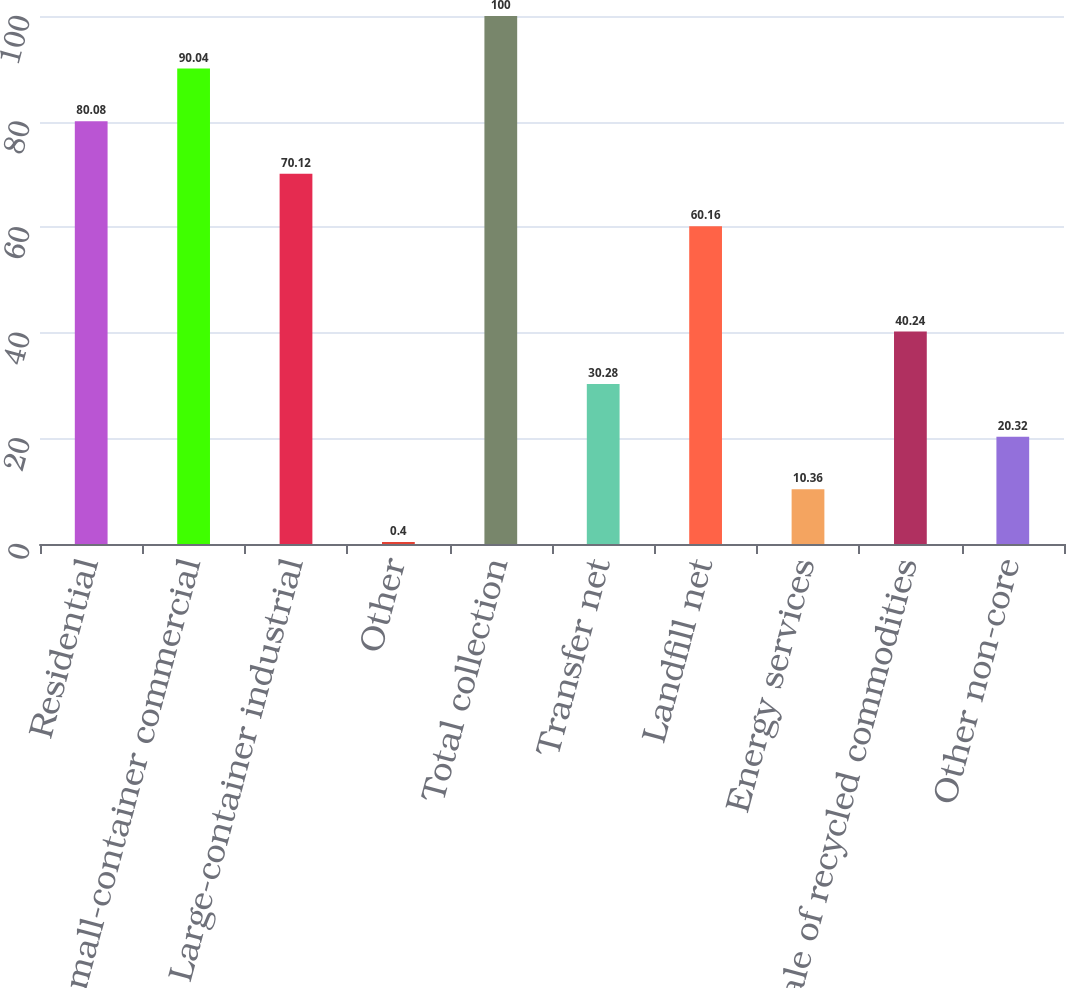<chart> <loc_0><loc_0><loc_500><loc_500><bar_chart><fcel>Residential<fcel>Small-container commercial<fcel>Large-container industrial<fcel>Other<fcel>Total collection<fcel>Transfer net<fcel>Landfill net<fcel>Energy services<fcel>Sale of recycled commodities<fcel>Other non-core<nl><fcel>80.08<fcel>90.04<fcel>70.12<fcel>0.4<fcel>100<fcel>30.28<fcel>60.16<fcel>10.36<fcel>40.24<fcel>20.32<nl></chart> 